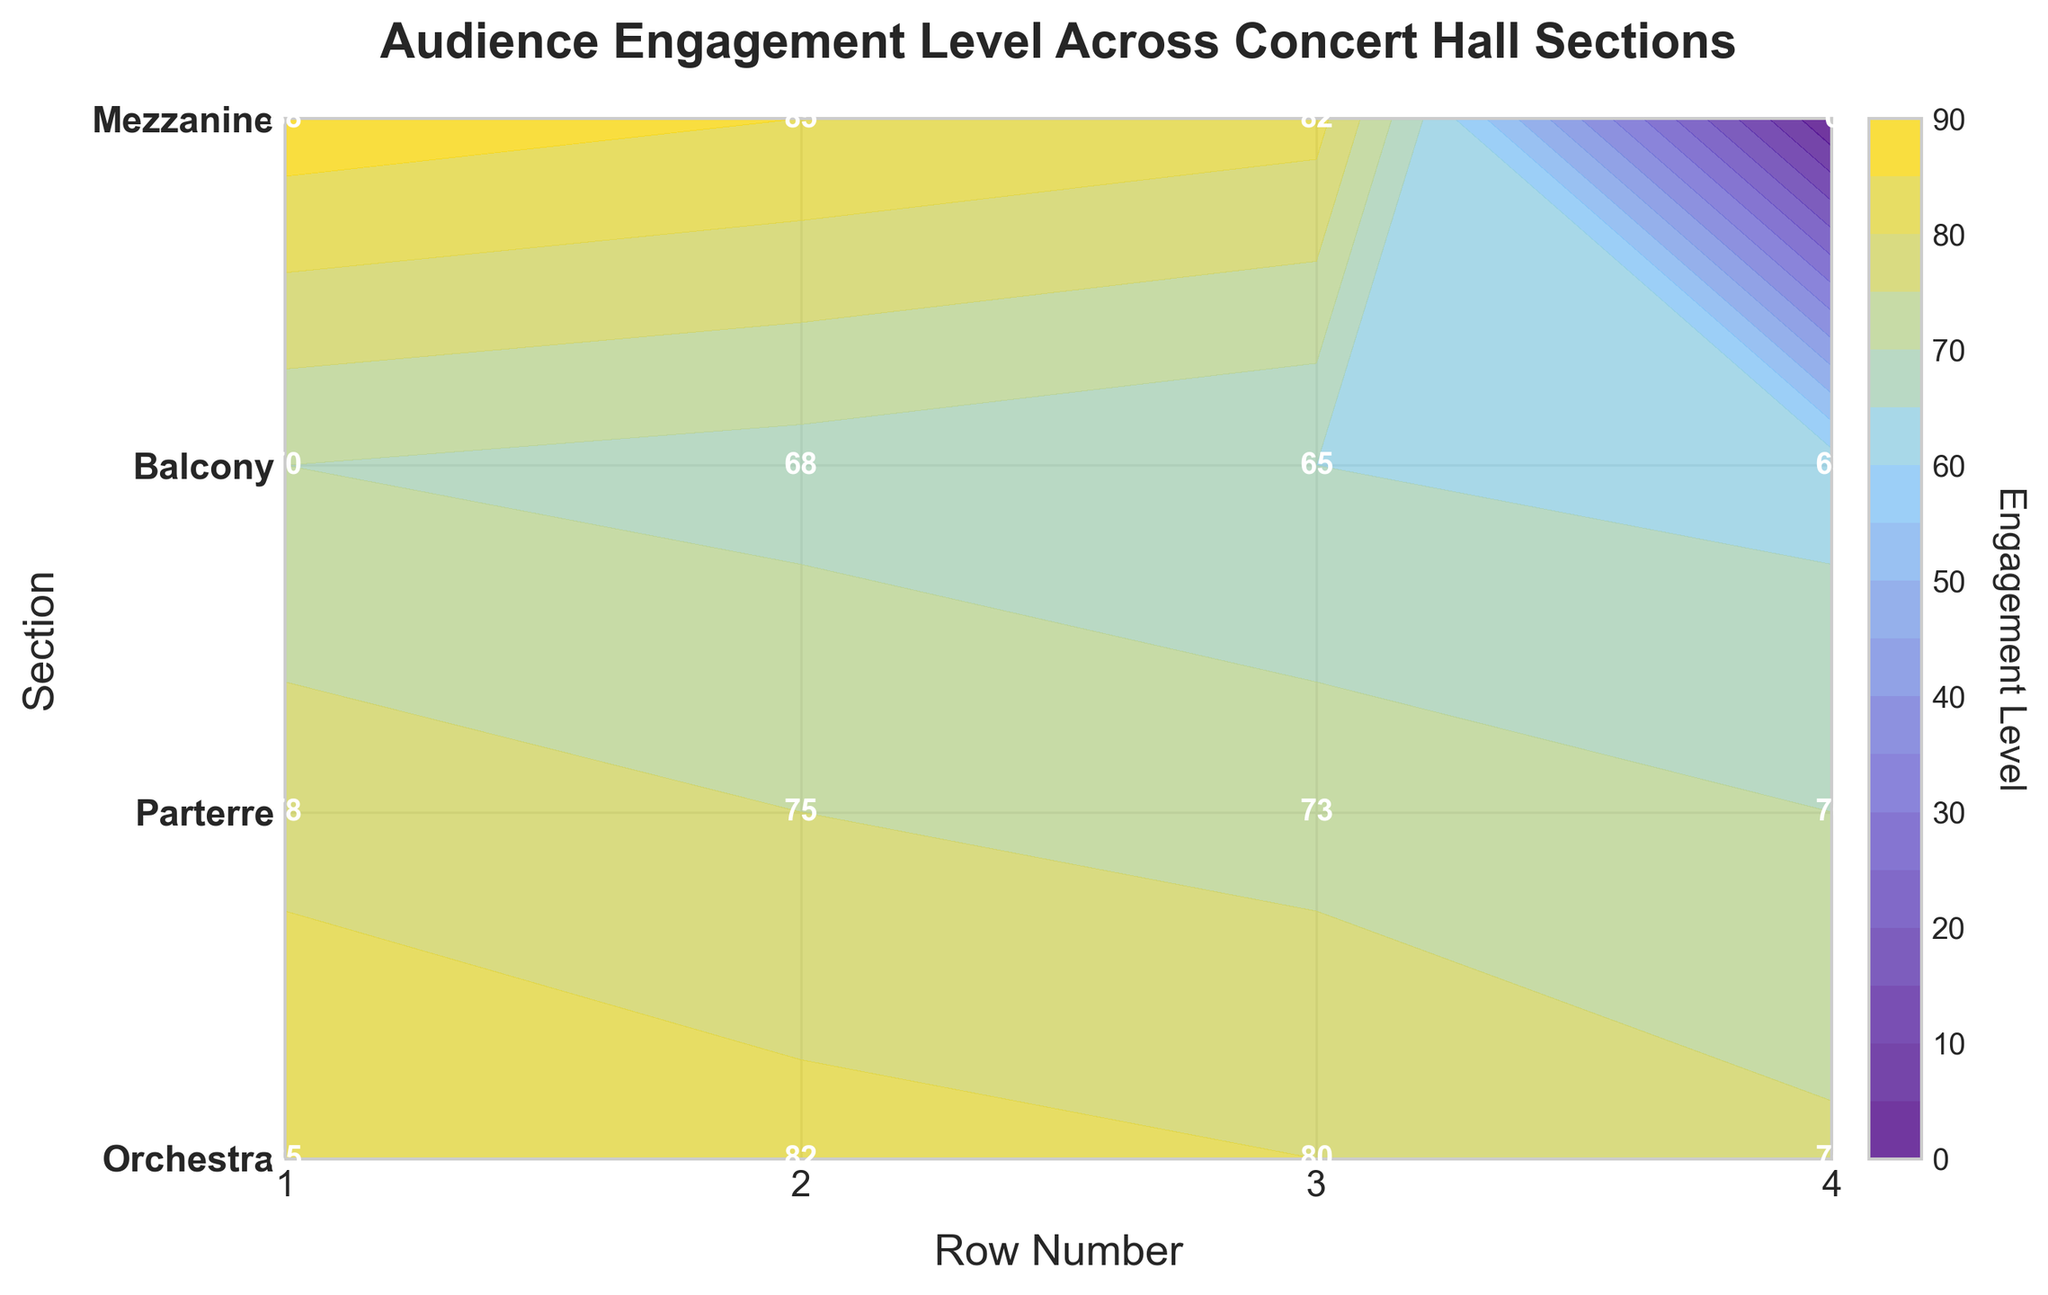What is the title of the plot? The title is located at the top of the plot. It reads "Audience Engagement Level Across Concert Hall Sections".
Answer: Audience Engagement Level Across Concert Hall Sections Which section has the highest engagement level in row 1? Find row 1 on the x-axis and locate the corresponding sections. The Mezzanine section in row 1 has the highest engagement level at 88.
Answer: Mezzanine Compare the engagement levels between the Orchestra and Parterre sections in row 2. Which one is higher? Look at the engagement levels for row 2 (x-axis) and compare the values for the Orchestra and Parterre sections. Orchestra has an engagement level of 82, while Parterre has an engagement level of 75. Orchestra is higher.
Answer: Orchestra What is the engagement level in Balcony section, row 4? Locate row 4 on the x-axis and find the corresponding engagement level in the Balcony section on the y-axis. It shows 63.
Answer: 63 What is the average engagement level in the Mezzanine section across all rows? Sum the engagement levels of the Mezzanine section across rows 1 to 4 and then divide by the number of rows (4). (88 + 85 + 82 + 0) / 4 = 63.75.
Answer: 63.75 Which section shows the most significant decrease in engagement level from row 1 to row 4? Calculate the difference in engagement levels from row 1 to row 4 for each section and identify the largest decrease. Orchestra: 85 to 76 (9), Parterre: 78 to 70 (8), Balcony: 70 to 63 (7), Mezzanine: 88 to 0 (88). The Mezzanine section has the most significant decrease.
Answer: Mezzanine Is the engagement level more consistent across rows in the Orchestra or Balcony section? Compare the engagement levels across rows for both sections. Orchestra: 85, 82, 80, 76; Balcony: 70, 68, 65, 63. The differences for Orchestra are smaller (9, 2, and 4) than for Balcony (7, 2, and 3), indicating more consistency in the Balcony section.
Answer: Orchestra Which section has the lowest average engagement level across all rows? Calculate the average engagement level for each section. Orchestra: (85+82+80+76)/4 = 80.75, Parterre: (78+75+73+70)/4 = 74, Balcony: (70+68+65+63)/4 = 66.5, Mezzanine: (88+85+82+0)/4 = 63.75. The Balcony section has the lowest average engagement level.
Answer: Balcony How do the engagement levels in row 3 compare across sections? Look at the engagement levels for row 3 across all sections. Orchestra: 80, Parterre: 73, Balcony: 65, Mezzanine: 82. Mezzanine has the highest engagement, followed by Orchestra, Parterre, and Balcony.
Answer: Mezzanine > Orchestra > Parterre > Balcony 